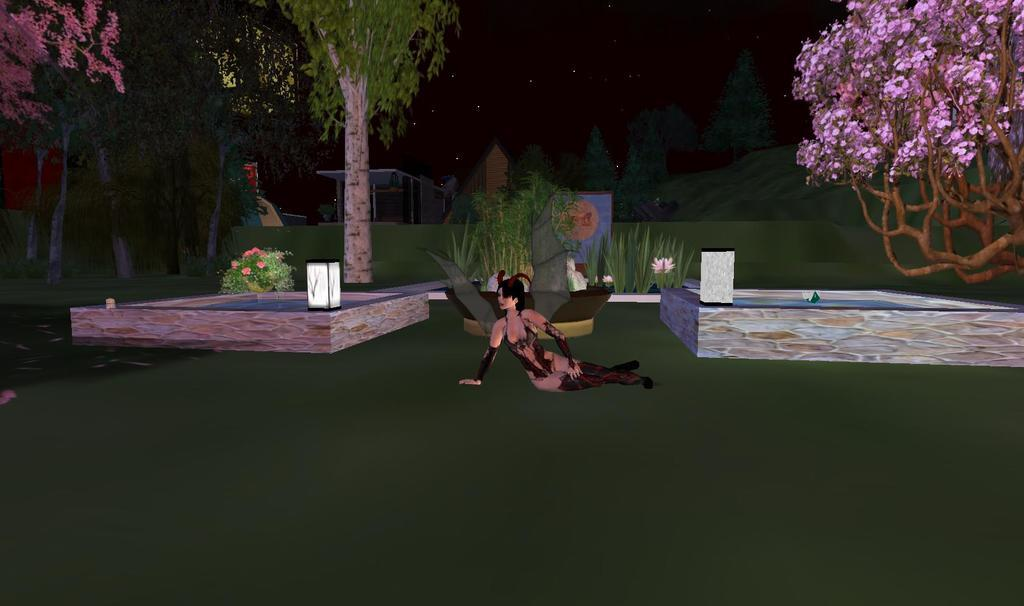What type of scene is depicted in the image? The image contains an animated scene. Can you describe the lady's position in the image? There is a lady on the ground in the image. What type of natural elements can be seen in the image? There are trees and plants in the image. What type of man-made structures are present in the image? There are buildings in the image. How would you describe the sky in the image? The sky is dark in the image. What type of mass can be seen on the lady's head in the image? There is no mass visible on the lady's head in the image. Can you describe the banana that the lady is holding in the image? There is no banana present in the image. What type of horn is being played by the lady in the image? There is no horn or any musical instrument being played by the lady in the image. 